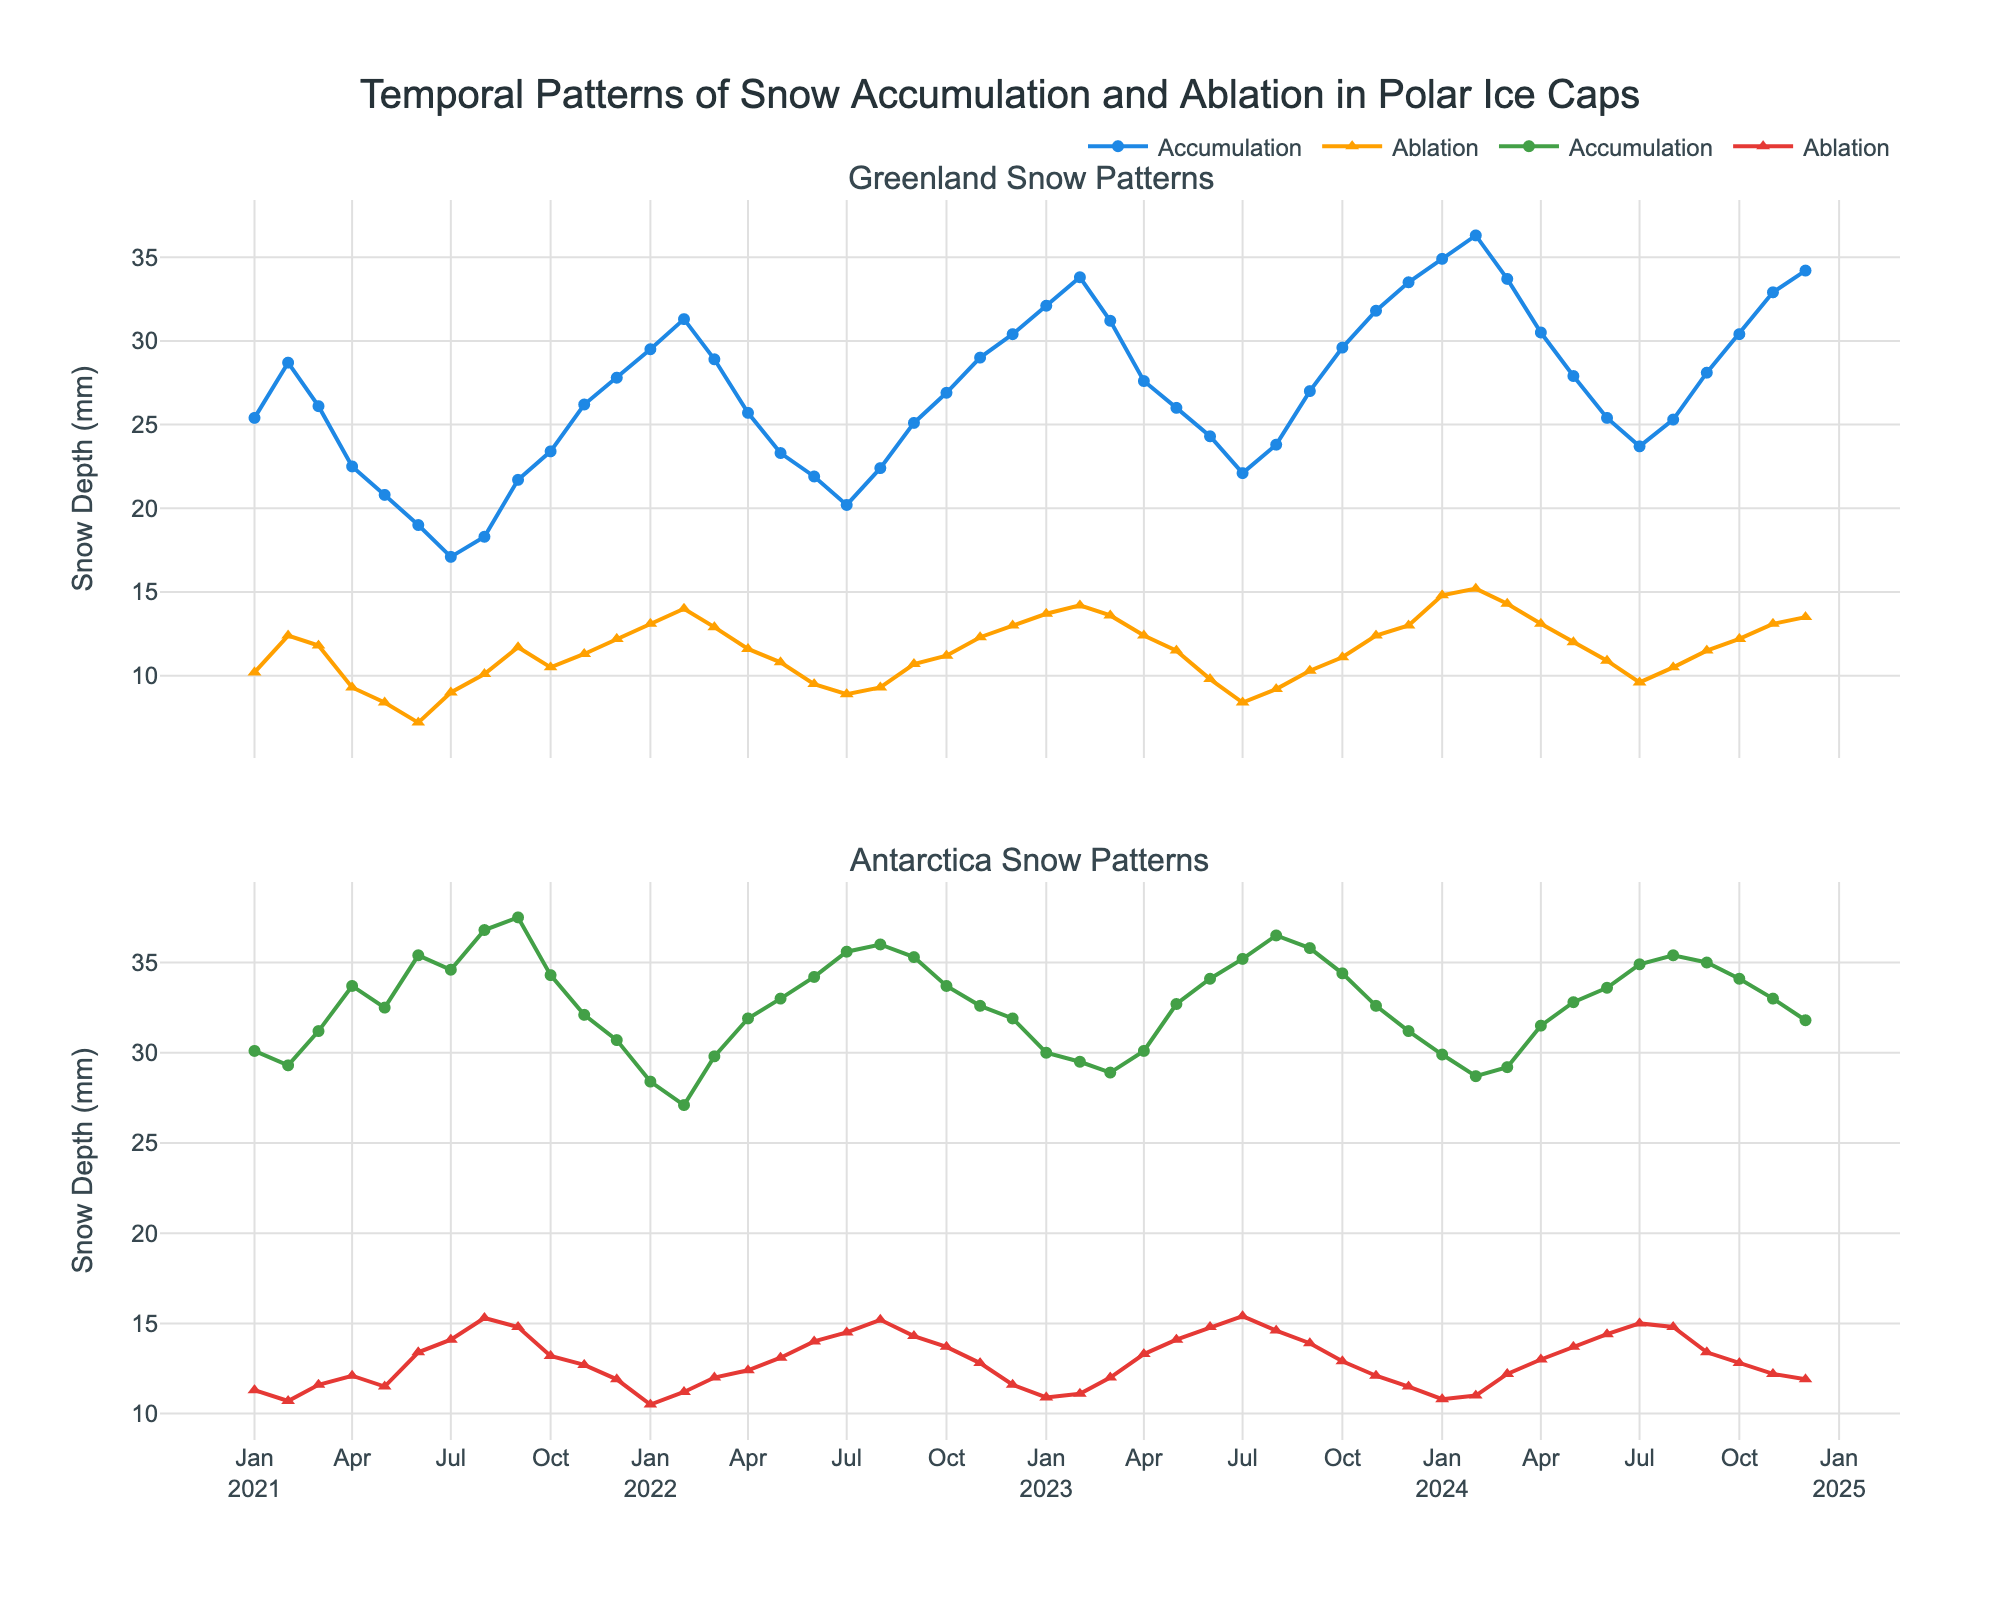What's the title of the figure? The title of the figure is shown at the top and reads "Temporal Patterns of Snow Accumulation and Ablation in Polar Ice Caps".
Answer: Temporal Patterns of Snow Accumulation and Ablation in Polar Ice Caps What are the two main regions depicted in the time series plot? The figure contains two subplots with titles "Greenland Snow Patterns" and "Antarctica Snow Patterns" representing the data for Greenland and Antarctica.
Answer: Greenland and Antarctica Which month showed the highest snow accumulation in Greenland in 2023? By examining the Greenland subplot for 2023, the highest peak in the blue line (accumulation) occurs in February 2023.
Answer: February What is the difference in snow accumulation between January 2021 and January 2022 in Antarctica? By looking at the green line in the Antarctica subplot, the accumulation in January 2021 is 30.1 mm and in January 2022 is 28.4 mm. The difference is 30.1 - 28.4.
Answer: 1.7 mm Which region exhibits higher snow ablation overall, Greenland or Antarctica? Comparing the orange and red lines across both subplots, Antarctica consistently shows higher snow ablation values compared to Greenland.
Answer: Antarctica Identify the month where Greenland experiences both the lowest accumulation and lowest ablation in 2023. In the Greenland subplot, the lowest values for both accumulation and ablation in 2023 occur in July 2023.
Answer: July 2023 What was the snow accumulation value in Antarctica in October 2024? In the Antarctica subplot, follow the green line to October 2024 to find an accumulation value of 34.1 mm.
Answer: 34.1 mm Comparing both regions, which month experienced the highest snow ablation in 2022? For both subplots, check each month in 2022; Greenland's highest ablation (orange line) is in February 2022 at 14.0 mm and Antarctica's highest ablation (red line) is in August 2022 at 15.2 mm, making August the highest overall.
Answer: August Did Greenland experience an increase or decrease in snow accumulation from May 2021 to June 2021? On the Greenland subplot, observe the blue line between May 2021 and June 2021 where the values drop from 20.8 mm to 19.0 mm, indicating a decrease.
Answer: Decrease Calculate the average snow accumulation in Antarctica for the year 2022. Sum the values of the green line in Antarctica for all months in 2022 (27.1, 29.8, 31.9, 33.0, 34.2, 35.6, 36.0, 35.3, 33.7, 32.6, 31.9, 30.0) and divide by 12.
Answer: 32.7 mm 